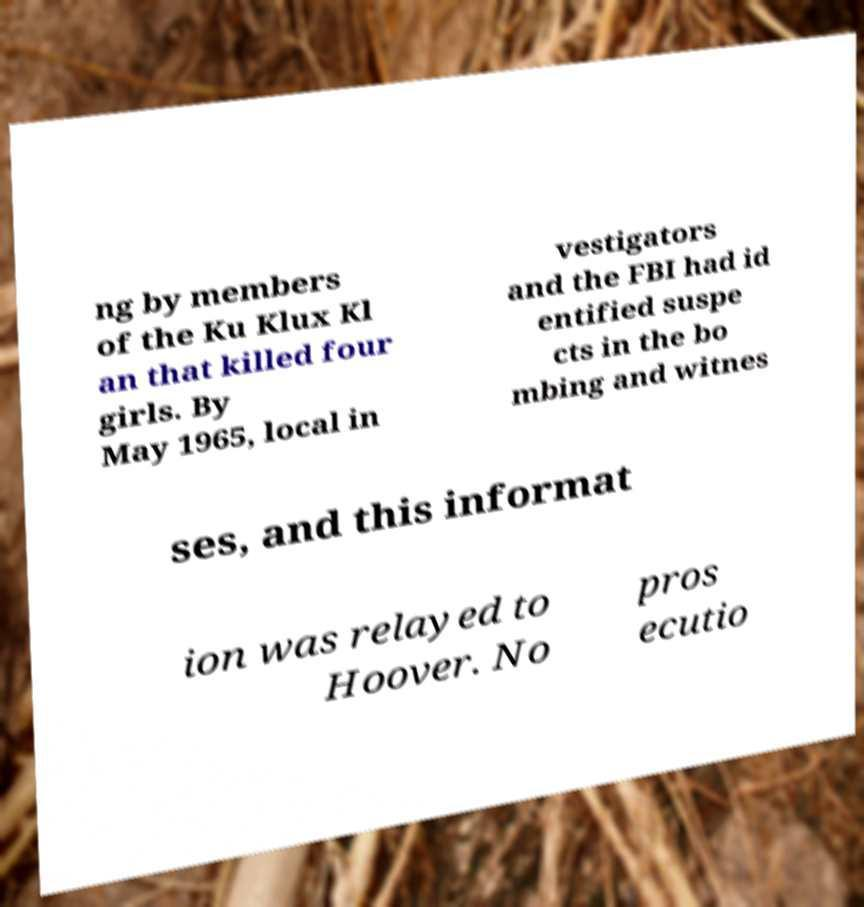Could you assist in decoding the text presented in this image and type it out clearly? ng by members of the Ku Klux Kl an that killed four girls. By May 1965, local in vestigators and the FBI had id entified suspe cts in the bo mbing and witnes ses, and this informat ion was relayed to Hoover. No pros ecutio 